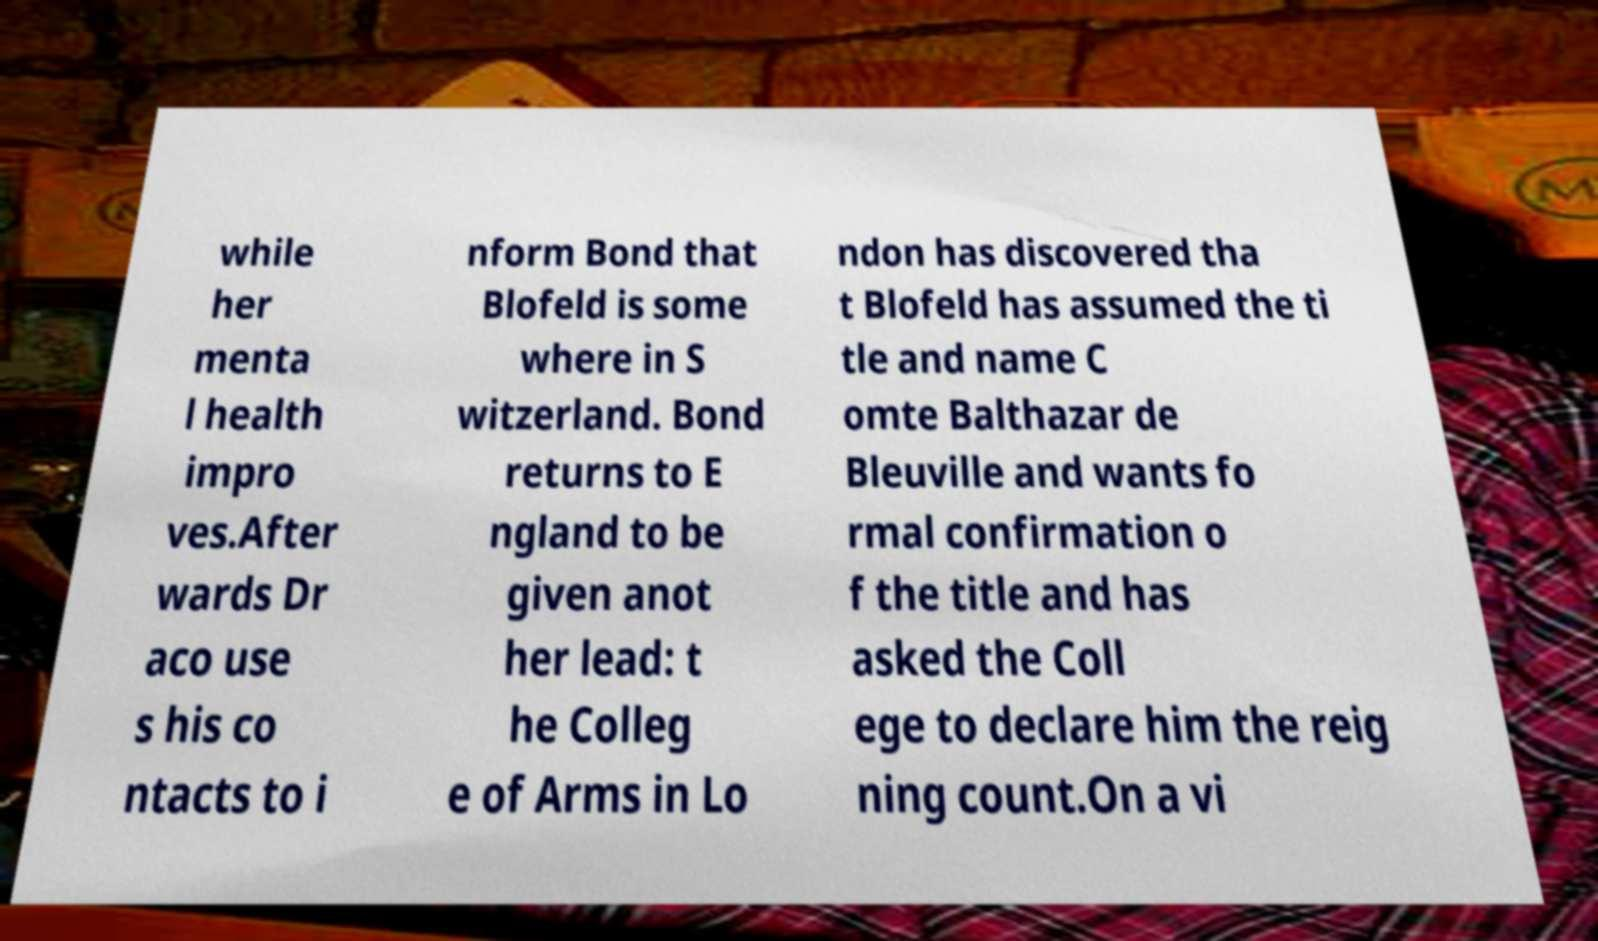What messages or text are displayed in this image? I need them in a readable, typed format. while her menta l health impro ves.After wards Dr aco use s his co ntacts to i nform Bond that Blofeld is some where in S witzerland. Bond returns to E ngland to be given anot her lead: t he Colleg e of Arms in Lo ndon has discovered tha t Blofeld has assumed the ti tle and name C omte Balthazar de Bleuville and wants fo rmal confirmation o f the title and has asked the Coll ege to declare him the reig ning count.On a vi 